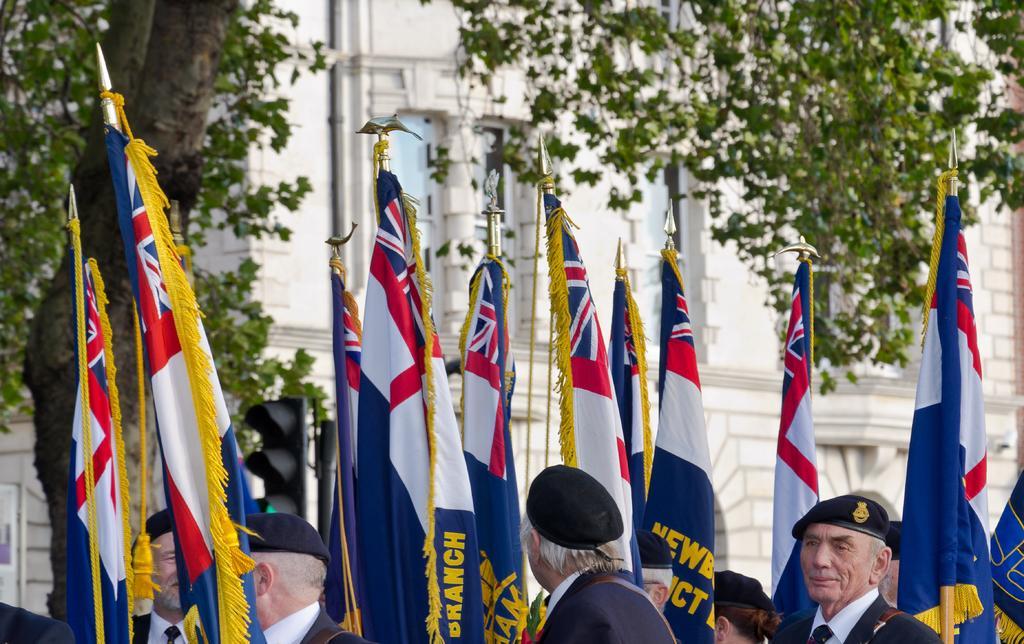Can you describe this image briefly? In this picture we can see few flags and group of people, they wore caps, in the background we can see traffic lights, trees and a building. 